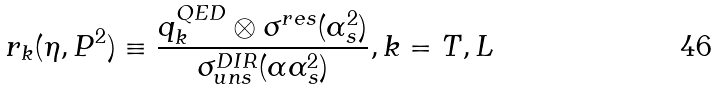<formula> <loc_0><loc_0><loc_500><loc_500>r _ { k } ( \eta , P ^ { 2 } ) \equiv \frac { q ^ { Q E D } _ { k } \otimes \sigma ^ { r e s } ( \alpha _ { s } ^ { 2 } ) } { \sigma ^ { D I R } _ { u n s } ( \alpha \alpha _ { s } ^ { 2 } ) } , k = T , L</formula> 